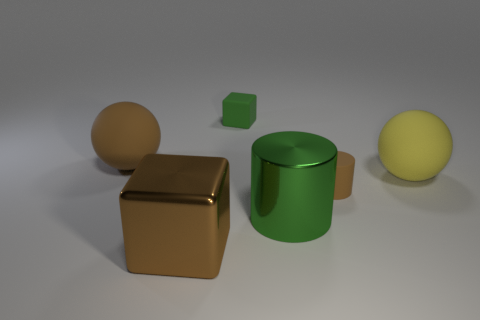Do the metallic cylinder and the brown cylinder have the same size?
Keep it short and to the point. No. Is there any other thing that has the same color as the big shiny cylinder?
Offer a terse response. Yes. There is a brown object that is both to the left of the brown matte cylinder and in front of the large yellow matte object; what is its shape?
Offer a terse response. Cube. How big is the green object that is in front of the yellow ball?
Your answer should be compact. Large. What number of rubber things are to the right of the shiny object that is to the left of the block behind the brown cylinder?
Your answer should be very brief. 3. Are there any metallic cylinders right of the small brown thing?
Offer a very short reply. No. How many other objects are there of the same size as the brown matte cylinder?
Your answer should be very brief. 1. What material is the thing that is to the right of the shiny cylinder and behind the small brown cylinder?
Keep it short and to the point. Rubber. Is the shape of the green object behind the shiny cylinder the same as the brown thing on the right side of the large brown block?
Ensure brevity in your answer.  No. Is there any other thing that is the same material as the yellow sphere?
Offer a very short reply. Yes. 